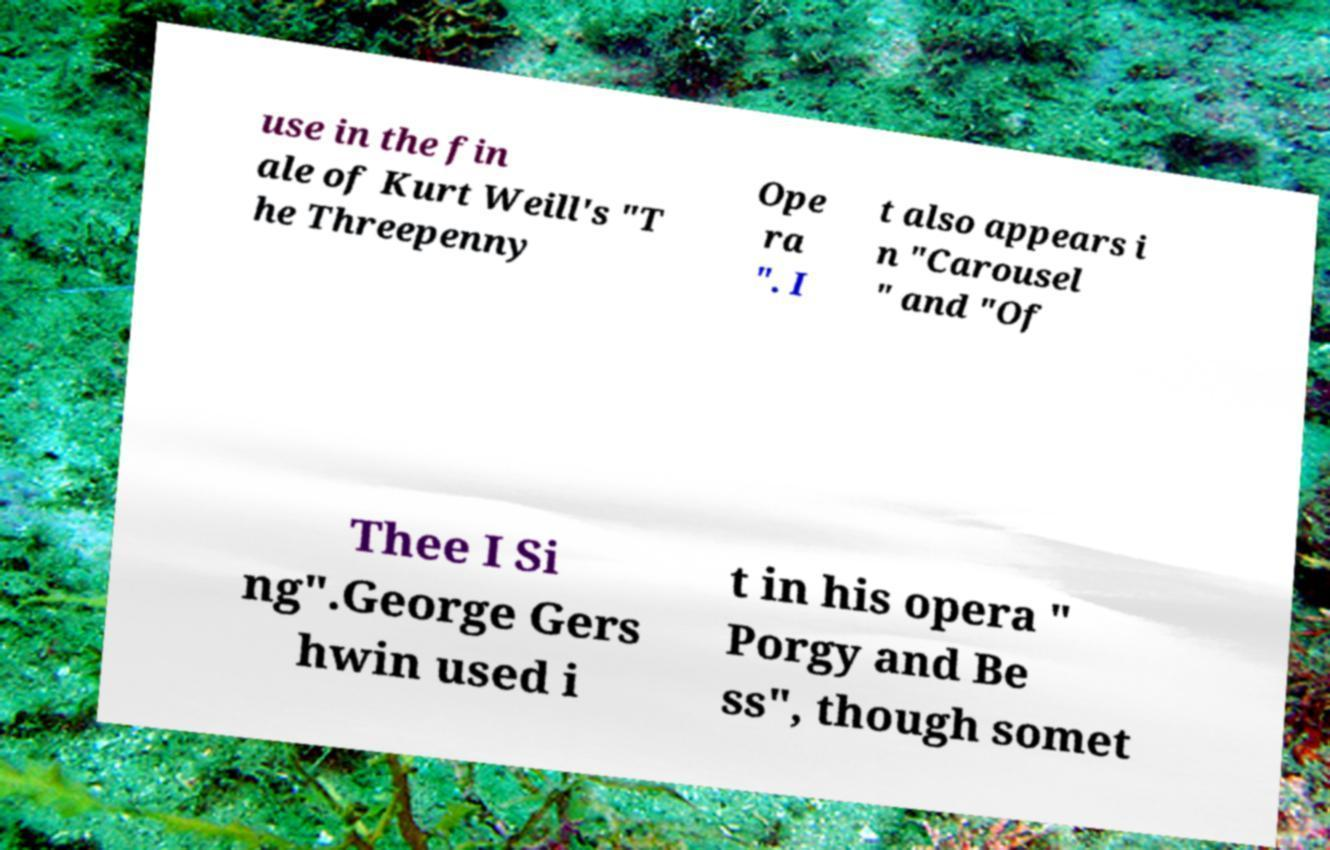Can you read and provide the text displayed in the image?This photo seems to have some interesting text. Can you extract and type it out for me? use in the fin ale of Kurt Weill's "T he Threepenny Ope ra ". I t also appears i n "Carousel " and "Of Thee I Si ng".George Gers hwin used i t in his opera " Porgy and Be ss", though somet 